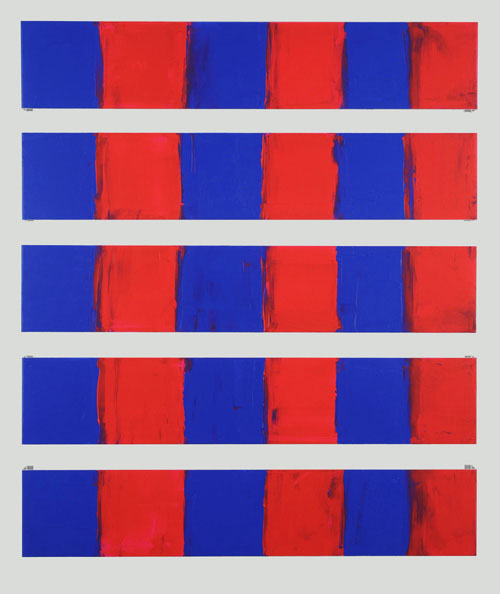How might the texture of the paint influence the perception of this artwork? The texture of the paint plays a crucial role in adding depth and dimension to the artwork. The thick, expressive strokes of the red paint introduce a tactile quality that might evoke a sense of movement or turbulence, suggesting a layer of emotional intensity. In contrast, the smoother blue sections can appear more static and calming. Together, they create a visual experience that engages not only the eye but also the viewer's sense of touch, albeit indirectly. 